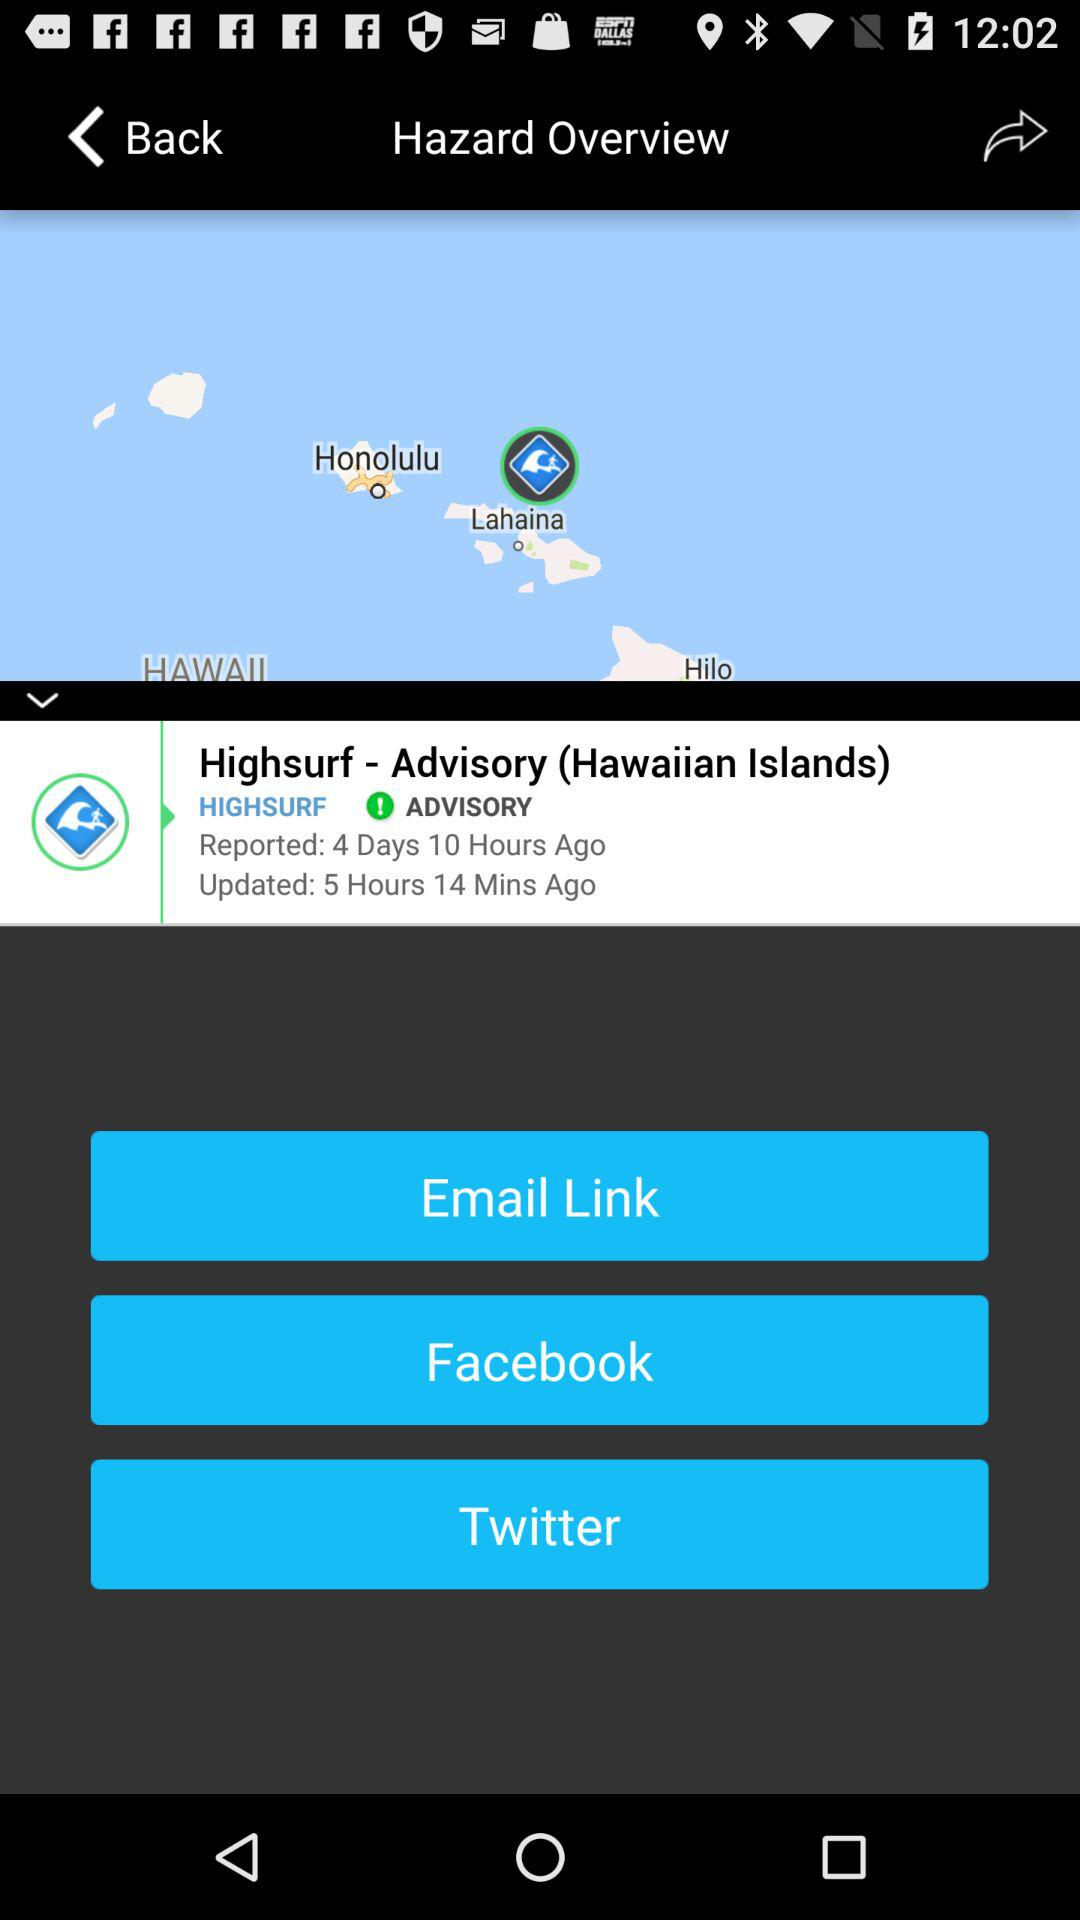What is the updated time? The updated time is 5 hours and 14 minutes ago. 